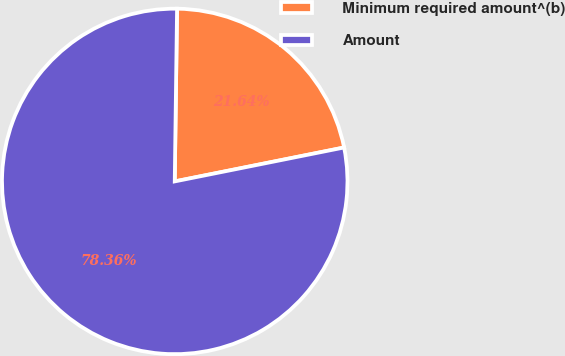Convert chart. <chart><loc_0><loc_0><loc_500><loc_500><pie_chart><fcel>Minimum required amount^(b)<fcel>Amount<nl><fcel>21.64%<fcel>78.36%<nl></chart> 